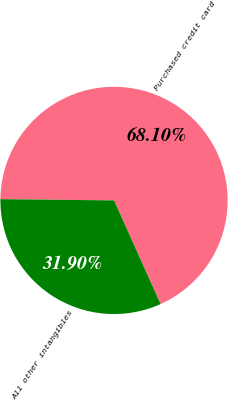Convert chart. <chart><loc_0><loc_0><loc_500><loc_500><pie_chart><fcel>Purchased credit card<fcel>All other intangibles<nl><fcel>68.1%<fcel>31.9%<nl></chart> 